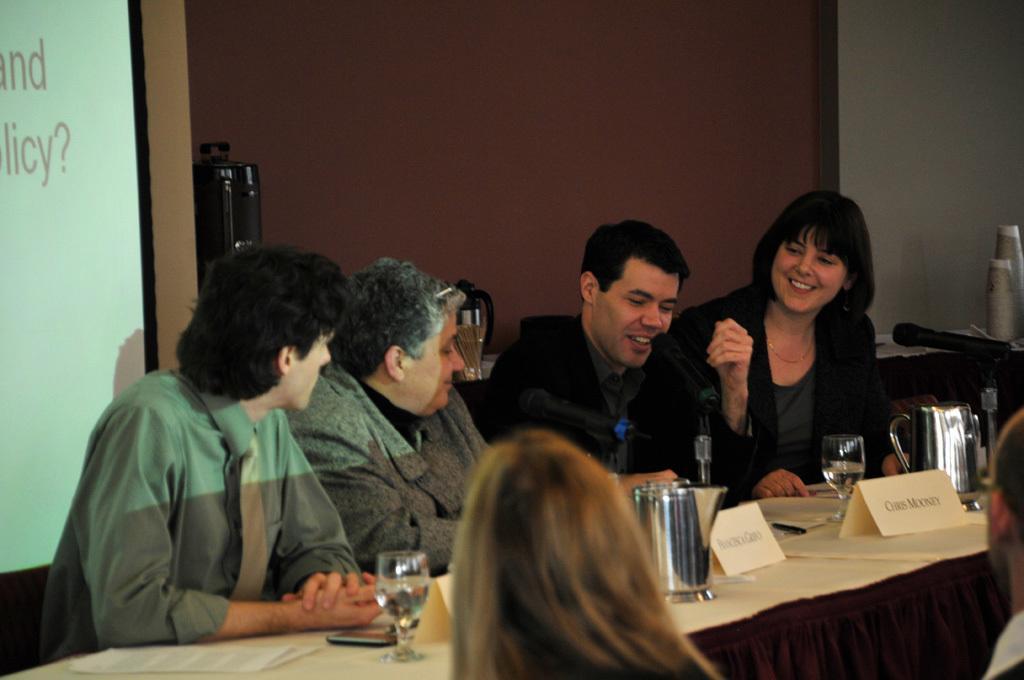In one or two sentences, can you explain what this image depicts? There are four members sitting in the chairs in front of a table on which name plates, glasses and some jars were placed. There are three men and a woman. There is a microphone on the table. In the background, there is a projector display screen and a wall here. 